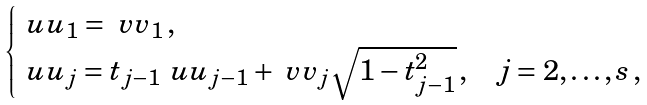Convert formula to latex. <formula><loc_0><loc_0><loc_500><loc_500>\begin{cases} \ u u _ { 1 } = \ v v _ { 1 } \, , & \\ \ u u _ { j } = t _ { j - 1 } \ u u _ { j - 1 } + \ v v _ { j } \sqrt { 1 - t _ { j - 1 } ^ { 2 } } \, , & j = 2 , \dots , s \, , \end{cases}</formula> 